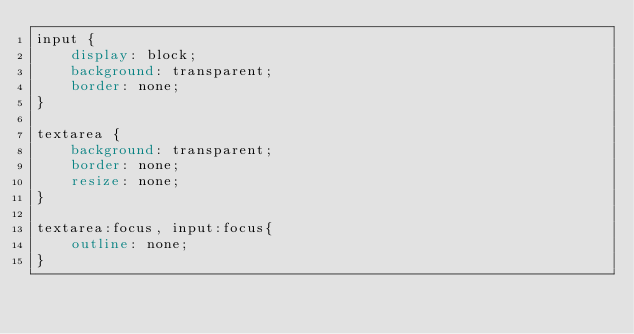<code> <loc_0><loc_0><loc_500><loc_500><_CSS_>input {
    display: block;
    background: transparent;
    border: none;
}

textarea {
    background: transparent;
    border: none;
    resize: none;
}

textarea:focus, input:focus{
    outline: none;
}</code> 